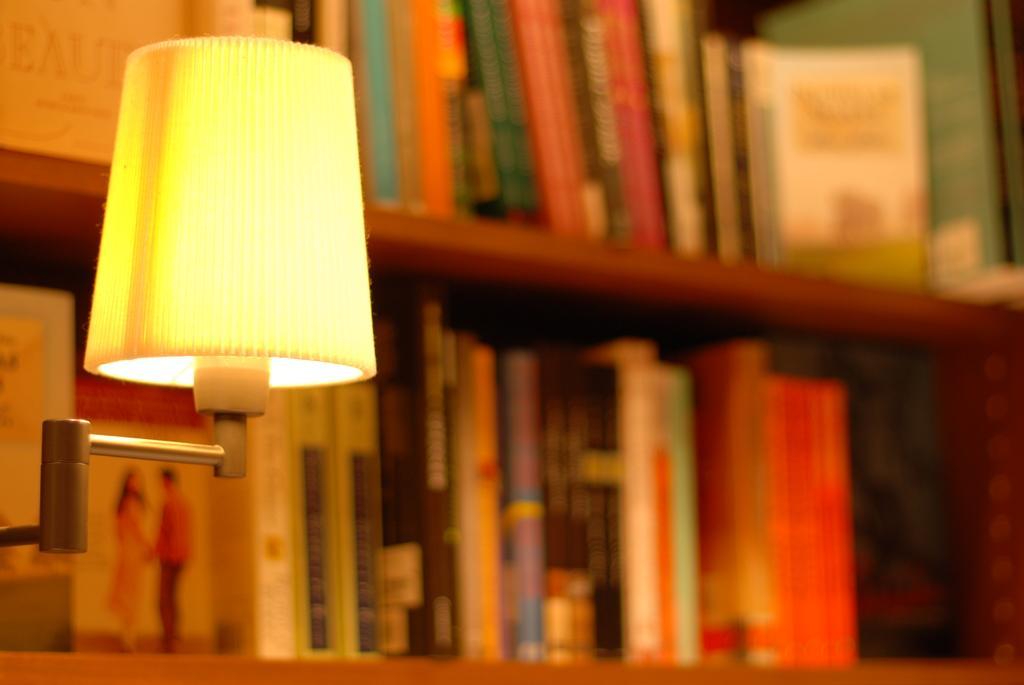How would you summarize this image in a sentence or two? In this image, we can see a lamp and in the background, there are books in the shelves. 